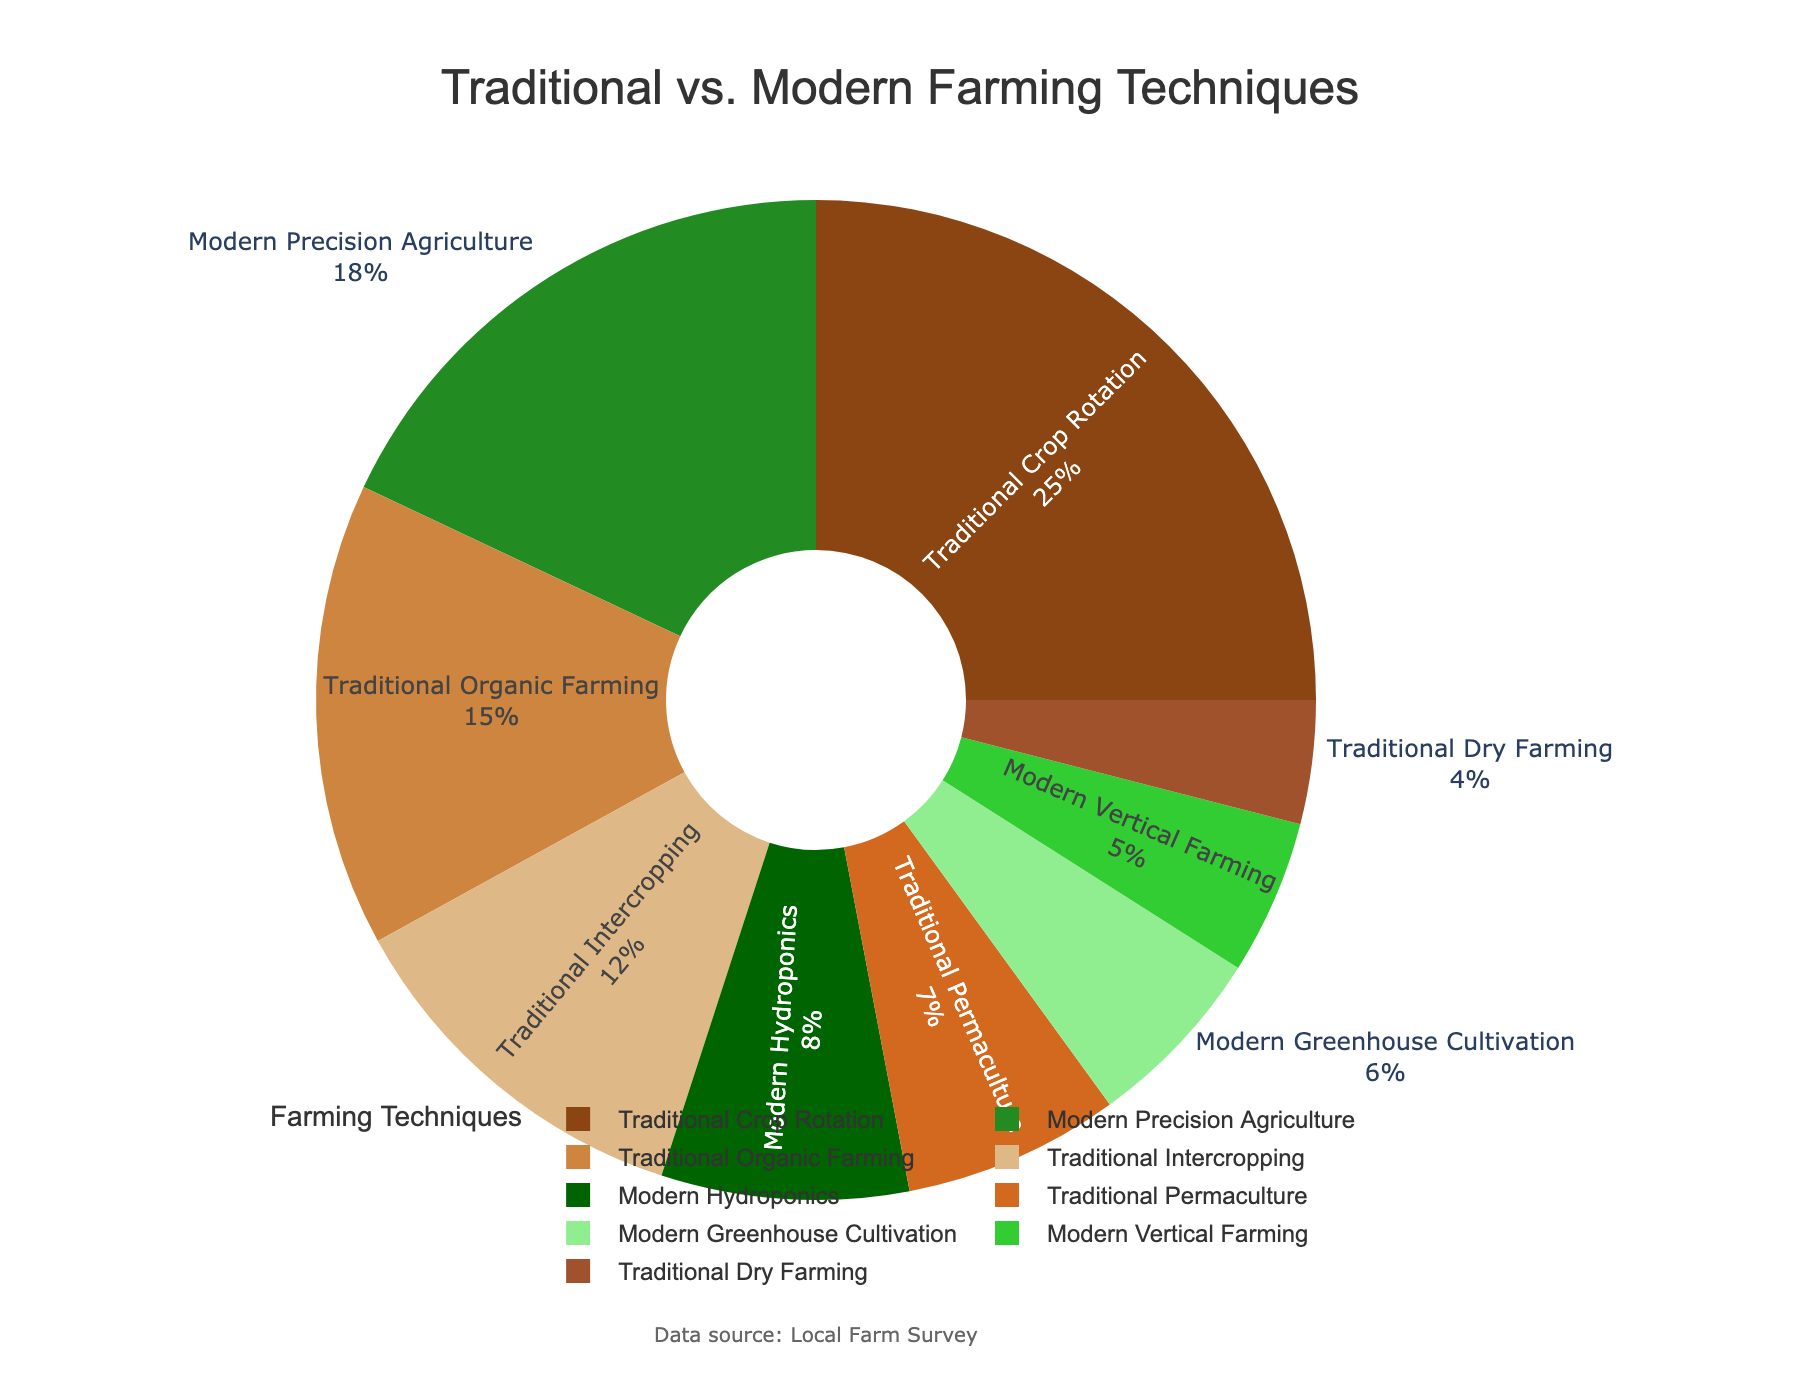Which farming technique has the highest percentage of use among farming households? Look at the pie chart and identify the segment with the largest percentage. In this case, it is "Traditional Crop Rotation" with 25%.
Answer: Traditional Crop Rotation How much more popular is Traditional Crop Rotation than Modern Precision Agriculture? Subtract the percentage of Modern Precision Agriculture (18%) from Traditional Crop Rotation (25%). So, 25% - 18% = 7%.
Answer: 7% What is the combined percentage of all traditional farming techniques? Add up the percentages of all traditional farming methods: Traditional Crop Rotation (25%), Traditional Organic Farming (15%), Traditional Intercropping (12%), Traditional Permaculture (7%), and Traditional Dry Farming (4%). The sum is 25% + 15% + 12% + 7% + 4% = 63%.
Answer: 63% What is the difference in percentage between the least used technique and the most used technique? Identify the least used technique which is Traditional Dry Farming (4%) and subtract it from the most used technique which is Traditional Crop Rotation (25%). 25% - 4% = 21%.
Answer: 21% Which modern farming technique has the least usage among farming households? Find the segment that represents the modern method with the lowest percentage. It is "Modern Vertical Farming" with 5%.
Answer: Modern Vertical Farming How much greater is the usage of Traditional Organic Farming compared to Modern Hydroponics? Subtract the percentage of Modern Hydroponics (8%) from Traditional Organic Farming (15%). So, 15% - 8% = 7%.
Answer: 7% What is the percentage difference between all traditional methods combined and all modern methods combined? First, calculate the total percentage for traditional methods: Traditional Crop Rotation (25%) + Traditional Organic Farming (15%) + Traditional Intercropping (12%) + Traditional Permaculture (7%) + Traditional Dry Farming (4%) = 63%. Next, calculate the total percentage for modern methods: Modern Precision Agriculture (18%) + Modern Hydroponics (8%) + Modern Vertical Farming (5%) + Modern Greenhouse Cultivation (6%) = 37%. Finally, subtract the total for modern methods from traditional methods: 63% - 37% = 26%.
Answer: 26% Which type of farming, traditional or modern, is more common among the surveyed households? Compare the total percentages of traditional methods (63%) and modern methods (37%). Traditional methods have a higher percentage.
Answer: Traditional What color represents Modern Precision Agriculture in the pie chart? Observe the segment of the pie chart labeled Modern Precision Agriculture and identify its color. It is green.
Answer: Green 